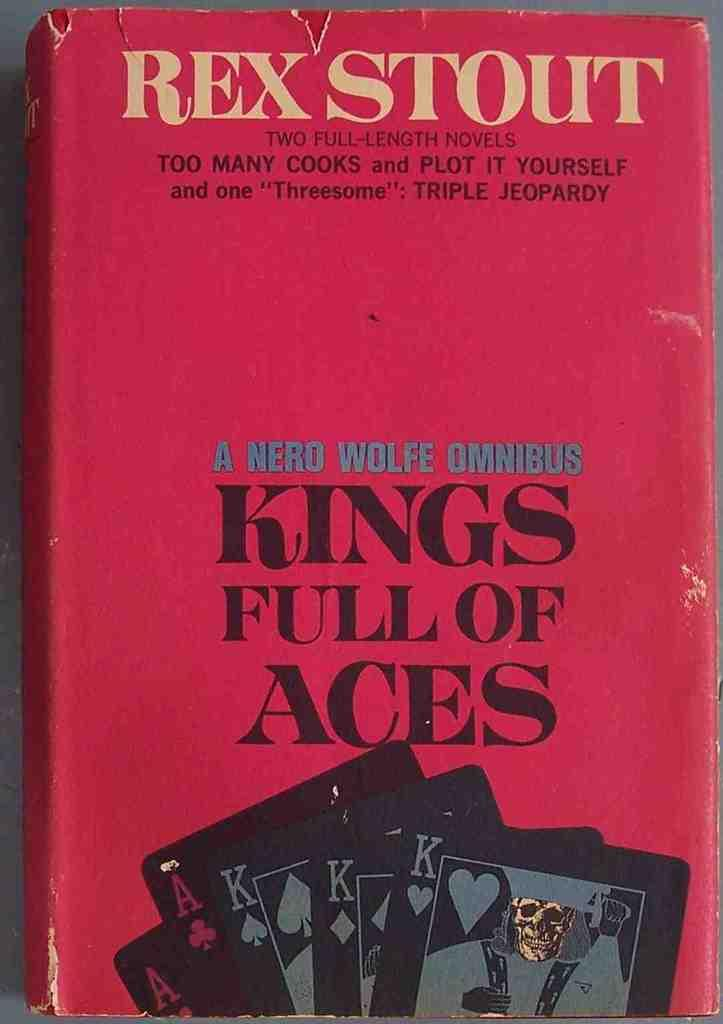<image>
Offer a succinct explanation of the picture presented. A book by Rex Scott titled Kings full of aces 